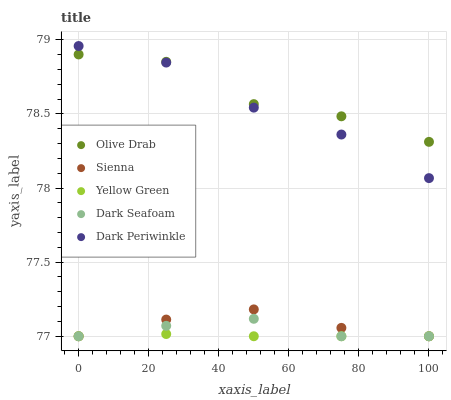Does Yellow Green have the minimum area under the curve?
Answer yes or no. Yes. Does Olive Drab have the maximum area under the curve?
Answer yes or no. Yes. Does Dark Seafoam have the minimum area under the curve?
Answer yes or no. No. Does Dark Seafoam have the maximum area under the curve?
Answer yes or no. No. Is Yellow Green the smoothest?
Answer yes or no. Yes. Is Olive Drab the roughest?
Answer yes or no. Yes. Is Dark Seafoam the smoothest?
Answer yes or no. No. Is Dark Seafoam the roughest?
Answer yes or no. No. Does Sienna have the lowest value?
Answer yes or no. Yes. Does Olive Drab have the lowest value?
Answer yes or no. No. Does Dark Periwinkle have the highest value?
Answer yes or no. Yes. Does Dark Seafoam have the highest value?
Answer yes or no. No. Is Sienna less than Olive Drab?
Answer yes or no. Yes. Is Olive Drab greater than Sienna?
Answer yes or no. Yes. Does Yellow Green intersect Dark Seafoam?
Answer yes or no. Yes. Is Yellow Green less than Dark Seafoam?
Answer yes or no. No. Is Yellow Green greater than Dark Seafoam?
Answer yes or no. No. Does Sienna intersect Olive Drab?
Answer yes or no. No. 